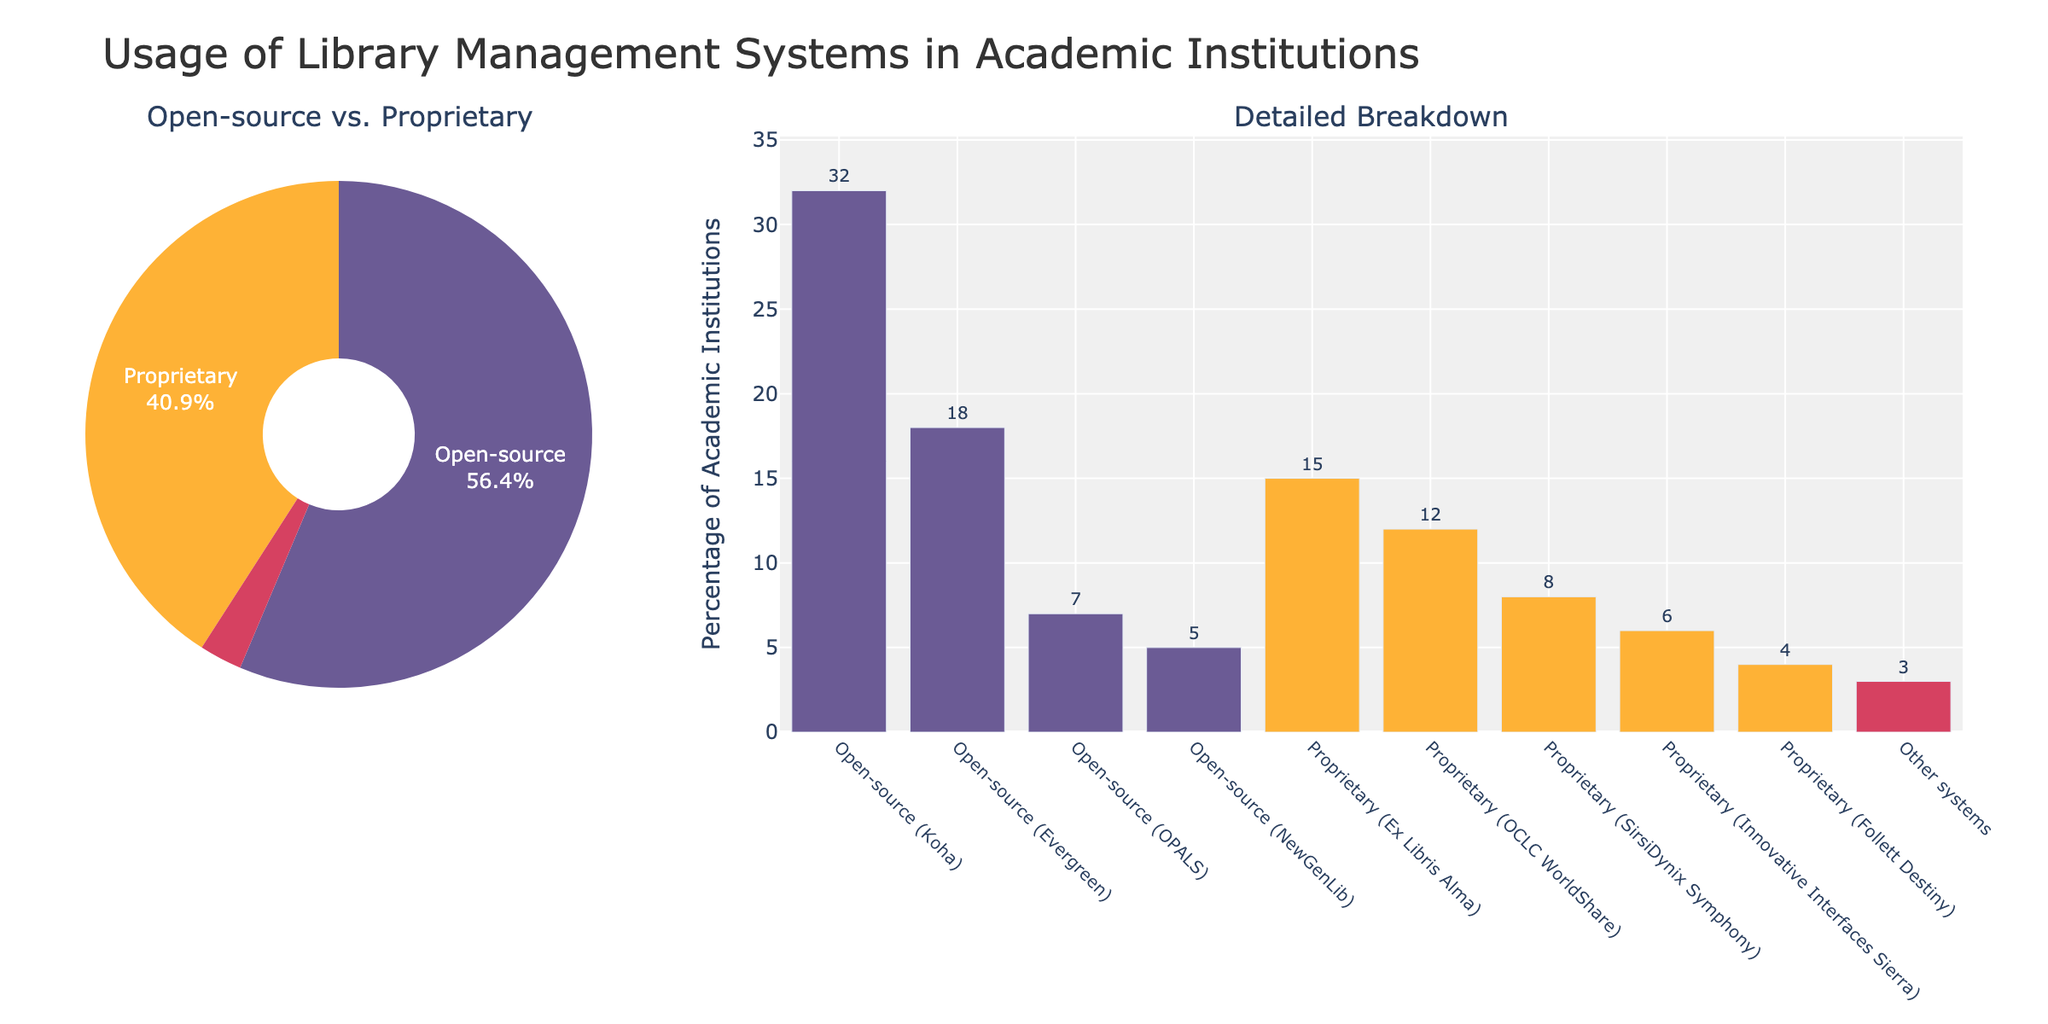What percentage of academic institutions use open-source library management systems? By looking at the pie chart, we can see the segment for open-source systems and its percentage. Adding the open-source percentages from the bar chart: Koha (32%), Evergreen (18%), OPALS (7%), NewGenLib (5%). So, 32 + 18 + 7 + 5 = 62%.
Answer: 62% Which library management system is most commonly used among academic institutions? From the bar chart, visually, the highest bar represents "Open-source (Koha)" indicating it has the highest usage.
Answer: Open-source (Koha) How does the usage of proprietary systems compare to open-source systems in academic institutions? Referring to the pie chart, we see the segments for both open-source and proprietary. The open-source segment is 62% and proprietary is 45%. Therefore, open-source systems are used more.
Answer: Open-source systems are used more What is the percentage difference between the most and least used proprietary systems? From the bar chart, the most used proprietary system is "Ex Libris Alma" at 15%, and the least used is "Follett Destiny" at 4%. The difference is 15 - 4 = 11%.
Answer: 11% What is the combined percentage of academic institutions using "Ex Libris Alma" and "OCLC WorldShare"? Referring to the bar chart, "Ex Libris Alma" is at 15% and "OCLC WorldShare" is at 12%. Adding these two values, 15 + 12 = 27%.
Answer: 27% Which open-source system has the lowest usage, and what is its percentage? Looking at the bar chart, among open-source systems, "NewGenLib" has the shortest bar with 5%.
Answer: Open-source (NewGenLib), 5% What is the usage percentage of "Innovative Interfaces Sierra" compared to "SirsiDynix Symphony"? According to the bar chart, "Innovative Interfaces Sierra" has 6% usage whereas "SirsiDynix Symphony" has 8% usage. "Innovative Interfaces Sierra" is used 2% less.
Answer: Innovative Interfaces Sierra is used 2% less What percentage of academic institutions are using systems other than open-source and proprietary? Referring to both the bar and pie charts, the "Other systems" category represents this segment, which is 3%.
Answer: 3% By how much does the usage of "Koha" exceed that of "SirsiDynix Symphony"? From the bar chart, "Koha" is at 32% and "SirsiDynix Symphony" is at 8%. The difference is 32 - 8 = 24%.
Answer: 24% What is the average usage percentage of all proprietary systems shown in the bar chart? The proprietary systems and their percentages are: Ex Libris Alma (15%), OCLC WorldShare (12%), SirsiDynix Symphony (8%), Innovative Interfaces Sierra (6%), Follett Destiny (4%). The sum is 15 + 12 + 8 + 6 + 4 = 45%. The number of proprietary systems is 5. Therefore, the average is 45 / 5 = 9%.
Answer: 9% 